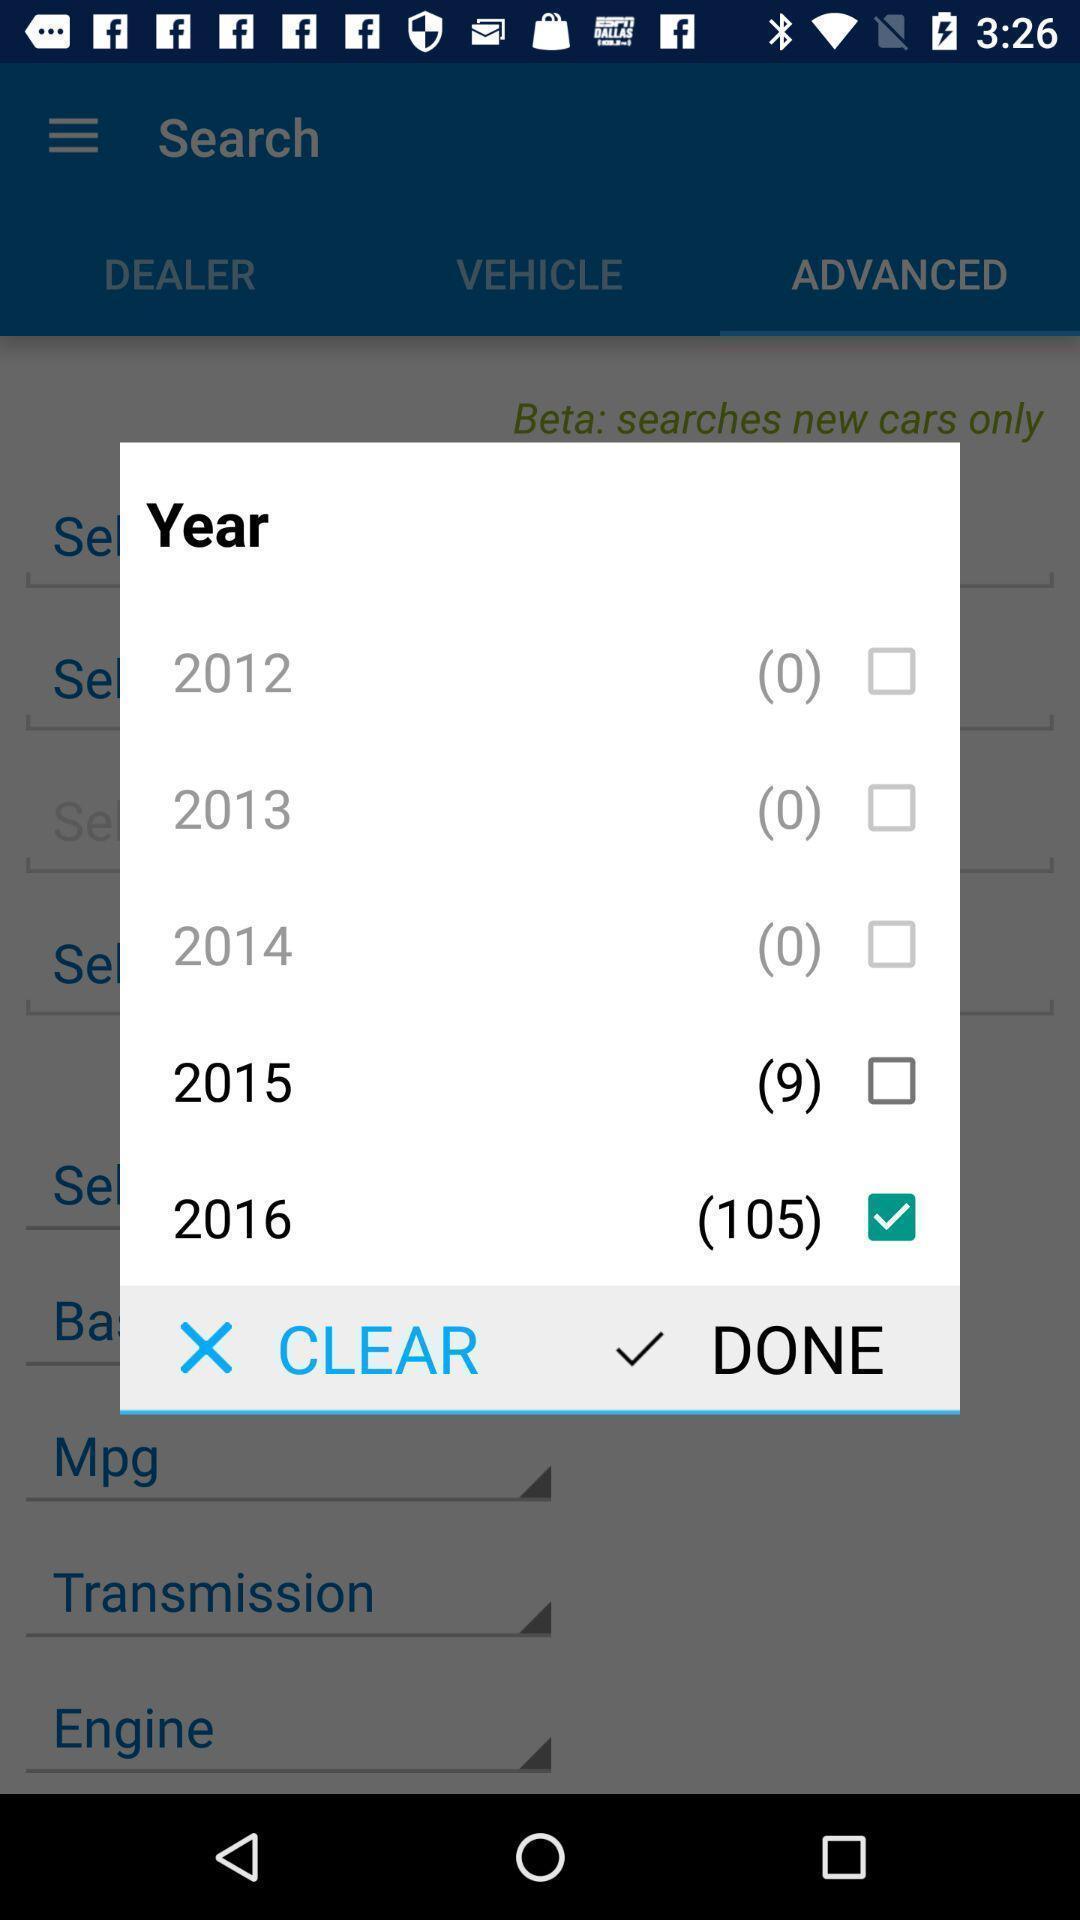Explain what's happening in this screen capture. Popup showing to select the year. 